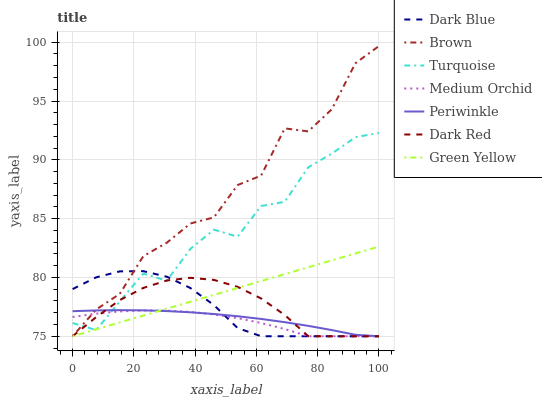Does Medium Orchid have the minimum area under the curve?
Answer yes or no. Yes. Does Brown have the maximum area under the curve?
Answer yes or no. Yes. Does Turquoise have the minimum area under the curve?
Answer yes or no. No. Does Turquoise have the maximum area under the curve?
Answer yes or no. No. Is Green Yellow the smoothest?
Answer yes or no. Yes. Is Brown the roughest?
Answer yes or no. Yes. Is Turquoise the smoothest?
Answer yes or no. No. Is Turquoise the roughest?
Answer yes or no. No. Does Brown have the lowest value?
Answer yes or no. Yes. Does Turquoise have the lowest value?
Answer yes or no. No. Does Brown have the highest value?
Answer yes or no. Yes. Does Turquoise have the highest value?
Answer yes or no. No. Does Medium Orchid intersect Brown?
Answer yes or no. Yes. Is Medium Orchid less than Brown?
Answer yes or no. No. Is Medium Orchid greater than Brown?
Answer yes or no. No. 